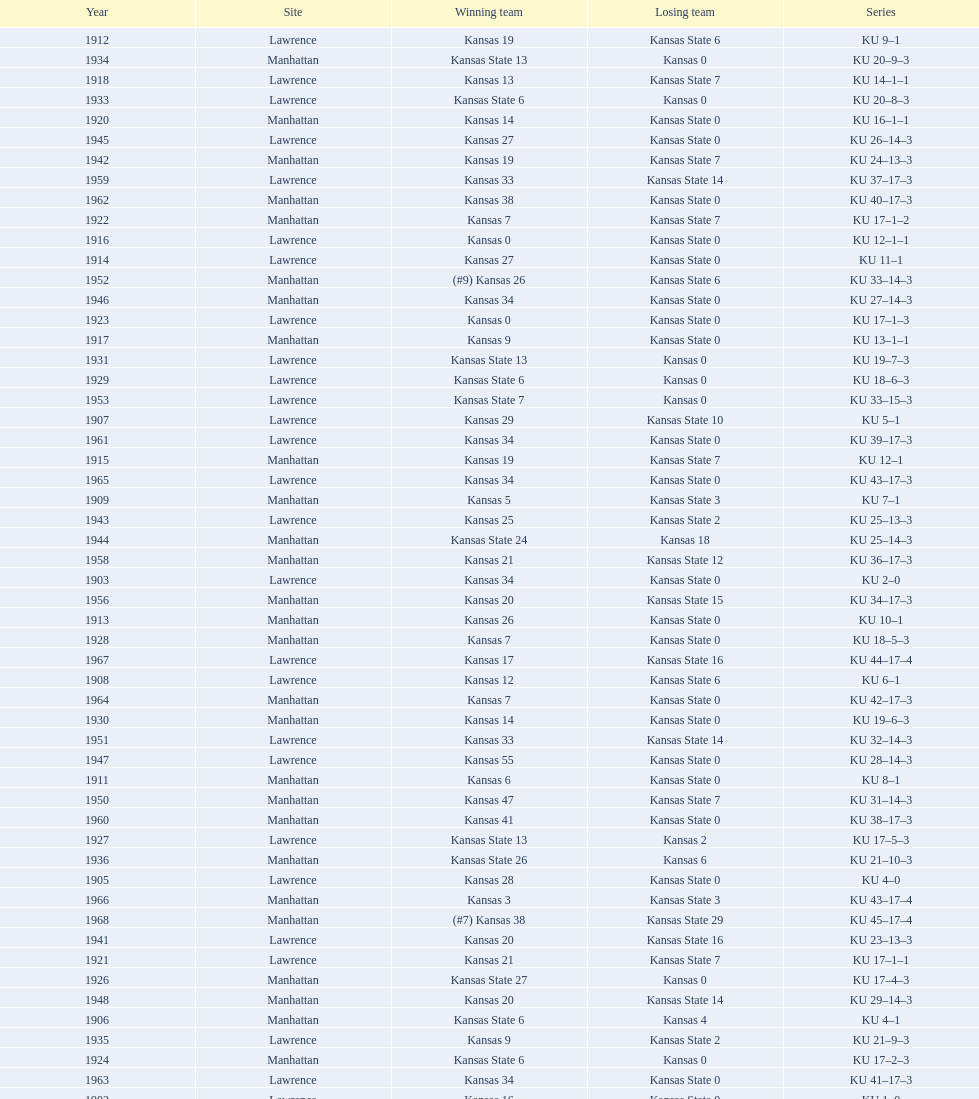What is the total number of games played? 66. 